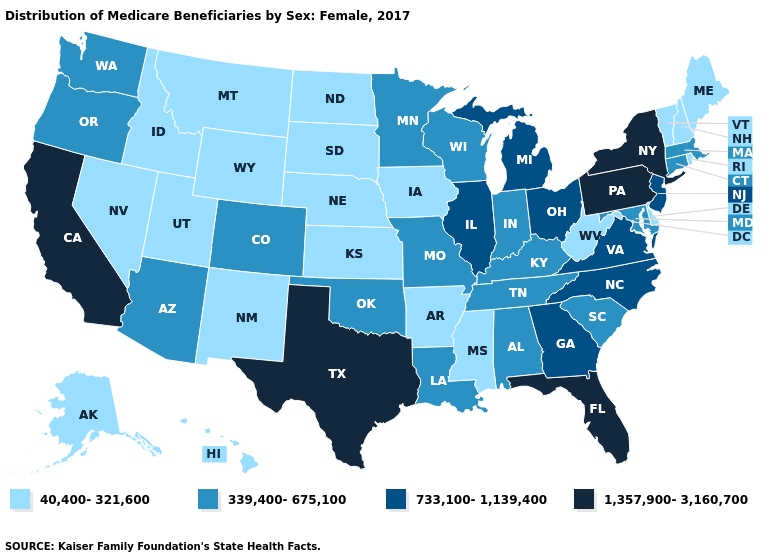What is the highest value in the USA?
Quick response, please. 1,357,900-3,160,700. Which states have the lowest value in the USA?
Quick response, please. Alaska, Arkansas, Delaware, Hawaii, Idaho, Iowa, Kansas, Maine, Mississippi, Montana, Nebraska, Nevada, New Hampshire, New Mexico, North Dakota, Rhode Island, South Dakota, Utah, Vermont, West Virginia, Wyoming. What is the value of Tennessee?
Quick response, please. 339,400-675,100. Does Washington have a higher value than Iowa?
Quick response, please. Yes. Which states have the highest value in the USA?
Short answer required. California, Florida, New York, Pennsylvania, Texas. Does New Jersey have the same value as Florida?
Give a very brief answer. No. What is the highest value in the MidWest ?
Be succinct. 733,100-1,139,400. What is the lowest value in states that border Colorado?
Give a very brief answer. 40,400-321,600. What is the value of Tennessee?
Give a very brief answer. 339,400-675,100. Does Mississippi have the lowest value in the South?
Quick response, please. Yes. Name the states that have a value in the range 1,357,900-3,160,700?
Answer briefly. California, Florida, New York, Pennsylvania, Texas. Which states have the lowest value in the MidWest?
Be succinct. Iowa, Kansas, Nebraska, North Dakota, South Dakota. What is the value of Michigan?
Concise answer only. 733,100-1,139,400. Does Arkansas have a lower value than Michigan?
Concise answer only. Yes. Which states have the lowest value in the USA?
Keep it brief. Alaska, Arkansas, Delaware, Hawaii, Idaho, Iowa, Kansas, Maine, Mississippi, Montana, Nebraska, Nevada, New Hampshire, New Mexico, North Dakota, Rhode Island, South Dakota, Utah, Vermont, West Virginia, Wyoming. 